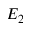<formula> <loc_0><loc_0><loc_500><loc_500>E _ { 2 }</formula> 